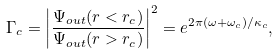Convert formula to latex. <formula><loc_0><loc_0><loc_500><loc_500>\Gamma _ { c } = \left | { \frac { \Psi _ { o u t } ( r < r _ { c } ) } { \Psi _ { o u t } ( r > r _ { c } ) } } \right | ^ { 2 } = e ^ { 2 \pi ( \omega + \omega _ { c } ) / \kappa _ { c } } ,</formula> 